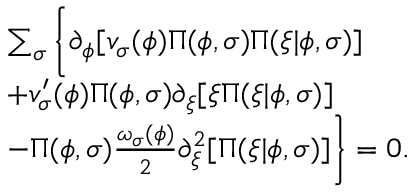<formula> <loc_0><loc_0><loc_500><loc_500>\begin{array} { r l } & { \sum _ { \sigma } \left \{ \partial _ { \phi } [ v _ { \sigma } ( \phi ) \Pi ( \phi , \sigma ) \Pi ( \xi | \phi , \sigma ) ] } \\ & { + v _ { \sigma } ^ { \prime } ( \phi ) \Pi ( \phi , \sigma ) \partial _ { \xi } [ \xi \Pi ( \xi | \phi , \sigma ) ] } \\ & { - \Pi ( \phi , \sigma ) \frac { \omega _ { \sigma } ( \phi ) } { 2 } \partial _ { \xi } ^ { 2 } [ \Pi ( \xi | \phi , \sigma ) ] \right \} = 0 . } \end{array}</formula> 